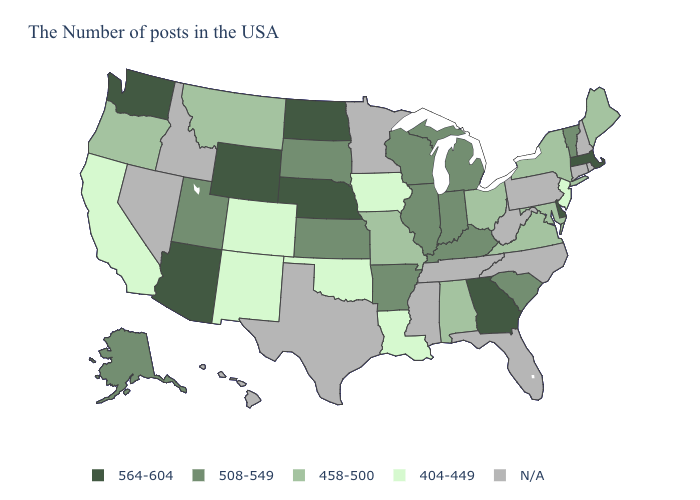Among the states that border Kansas , which have the lowest value?
Answer briefly. Oklahoma, Colorado. Which states have the lowest value in the MidWest?
Short answer required. Iowa. Among the states that border Nebraska , which have the lowest value?
Give a very brief answer. Iowa, Colorado. Which states hav the highest value in the South?
Concise answer only. Delaware, Georgia. What is the value of Ohio?
Answer briefly. 458-500. What is the value of West Virginia?
Answer briefly. N/A. Name the states that have a value in the range N/A?
Short answer required. Rhode Island, New Hampshire, Connecticut, Pennsylvania, North Carolina, West Virginia, Florida, Tennessee, Mississippi, Minnesota, Texas, Idaho, Nevada, Hawaii. Name the states that have a value in the range 458-500?
Concise answer only. Maine, New York, Maryland, Virginia, Ohio, Alabama, Missouri, Montana, Oregon. Name the states that have a value in the range 508-549?
Answer briefly. Vermont, South Carolina, Michigan, Kentucky, Indiana, Wisconsin, Illinois, Arkansas, Kansas, South Dakota, Utah, Alaska. Does the map have missing data?
Keep it brief. Yes. Name the states that have a value in the range 508-549?
Keep it brief. Vermont, South Carolina, Michigan, Kentucky, Indiana, Wisconsin, Illinois, Arkansas, Kansas, South Dakota, Utah, Alaska. Name the states that have a value in the range 508-549?
Write a very short answer. Vermont, South Carolina, Michigan, Kentucky, Indiana, Wisconsin, Illinois, Arkansas, Kansas, South Dakota, Utah, Alaska. Name the states that have a value in the range 404-449?
Keep it brief. New Jersey, Louisiana, Iowa, Oklahoma, Colorado, New Mexico, California. 